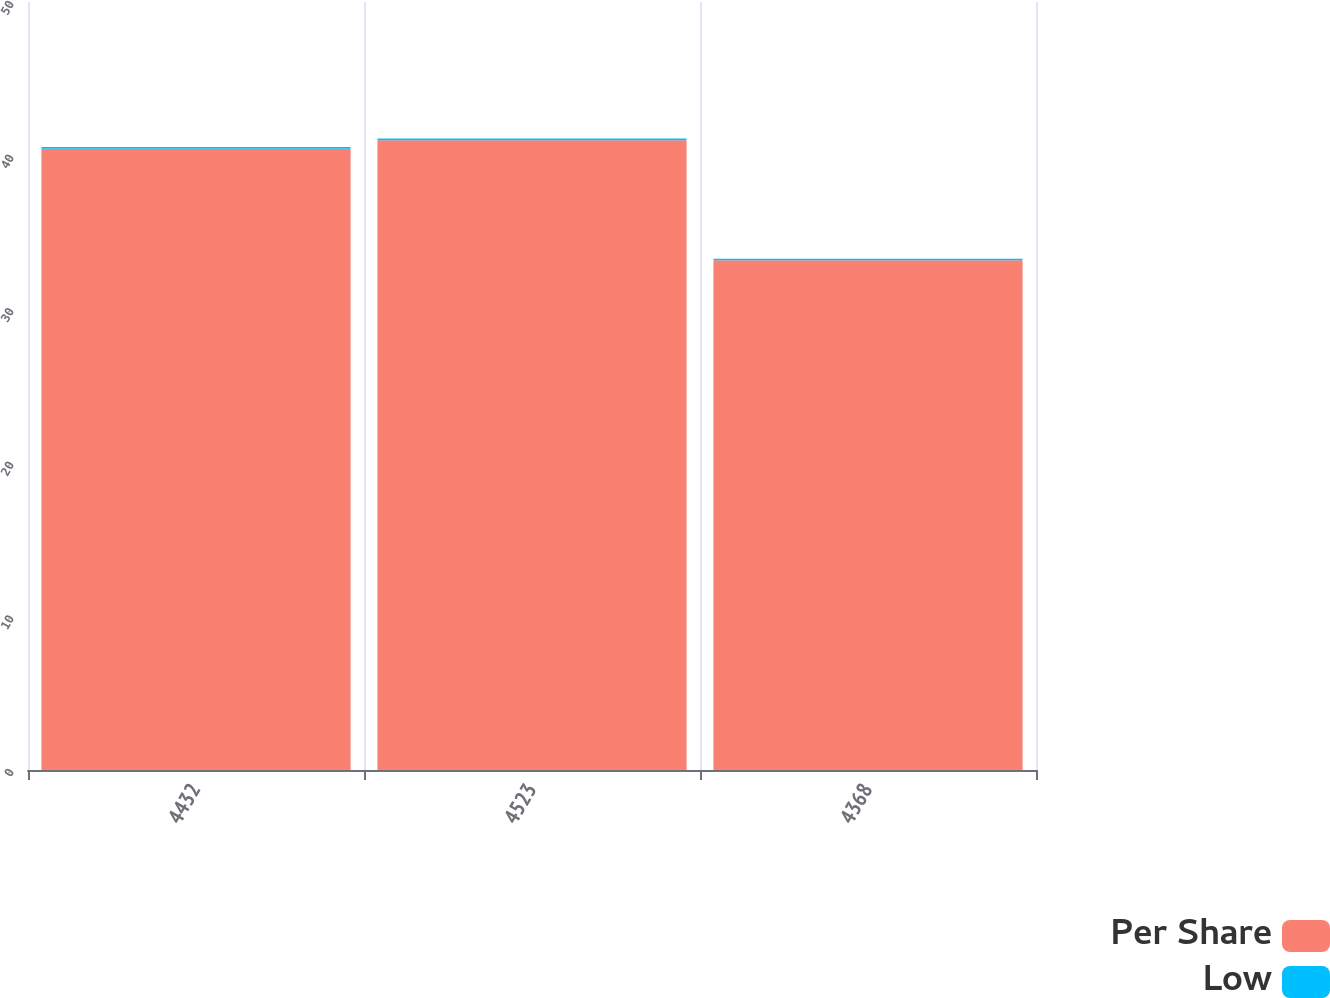Convert chart. <chart><loc_0><loc_0><loc_500><loc_500><stacked_bar_chart><ecel><fcel>4432<fcel>4523<fcel>4368<nl><fcel>Per Share<fcel>40.45<fcel>41<fcel>33.18<nl><fcel>Low<fcel>0.11<fcel>0.11<fcel>0.11<nl></chart> 